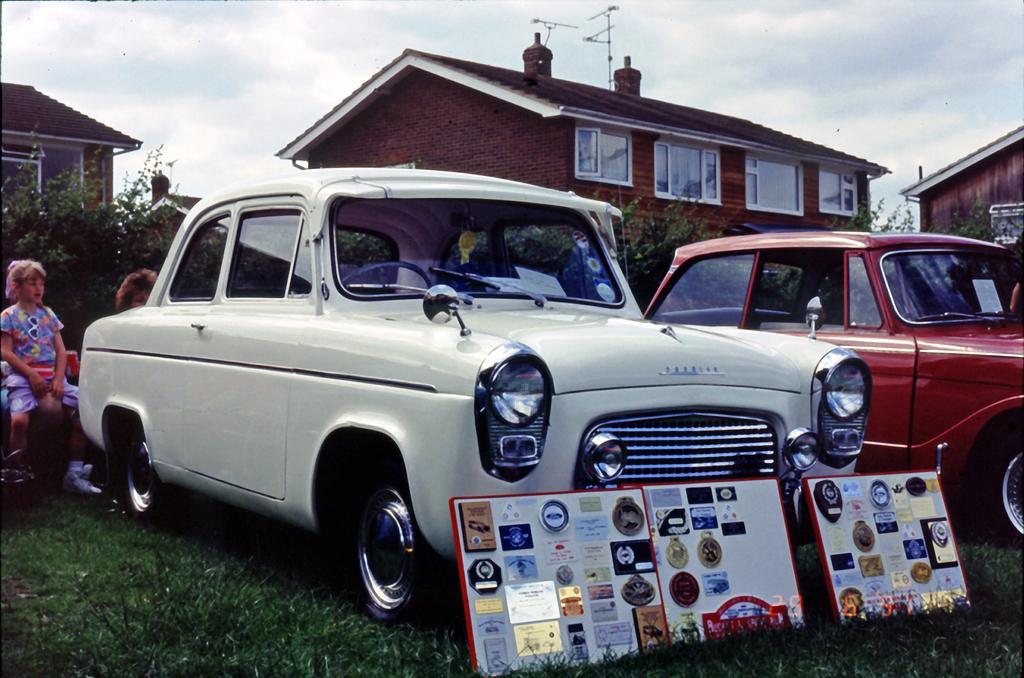Please provide a concise description of this image. In this image there are cars parked on the ground. There are boards in front of the cars. There is grass on the ground. Behind the cars there are a few people sitting. In the background there are houses and plants. At the top there is the sky. 